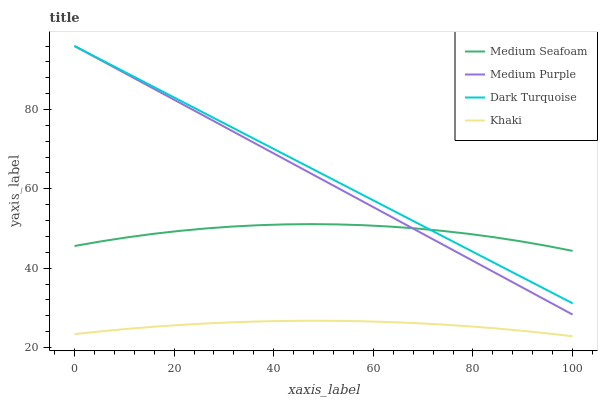Does Khaki have the minimum area under the curve?
Answer yes or no. Yes. Does Dark Turquoise have the maximum area under the curve?
Answer yes or no. Yes. Does Dark Turquoise have the minimum area under the curve?
Answer yes or no. No. Does Khaki have the maximum area under the curve?
Answer yes or no. No. Is Medium Purple the smoothest?
Answer yes or no. Yes. Is Medium Seafoam the roughest?
Answer yes or no. Yes. Is Dark Turquoise the smoothest?
Answer yes or no. No. Is Dark Turquoise the roughest?
Answer yes or no. No. Does Khaki have the lowest value?
Answer yes or no. Yes. Does Dark Turquoise have the lowest value?
Answer yes or no. No. Does Dark Turquoise have the highest value?
Answer yes or no. Yes. Does Khaki have the highest value?
Answer yes or no. No. Is Khaki less than Medium Seafoam?
Answer yes or no. Yes. Is Medium Seafoam greater than Khaki?
Answer yes or no. Yes. Does Medium Purple intersect Dark Turquoise?
Answer yes or no. Yes. Is Medium Purple less than Dark Turquoise?
Answer yes or no. No. Is Medium Purple greater than Dark Turquoise?
Answer yes or no. No. Does Khaki intersect Medium Seafoam?
Answer yes or no. No. 